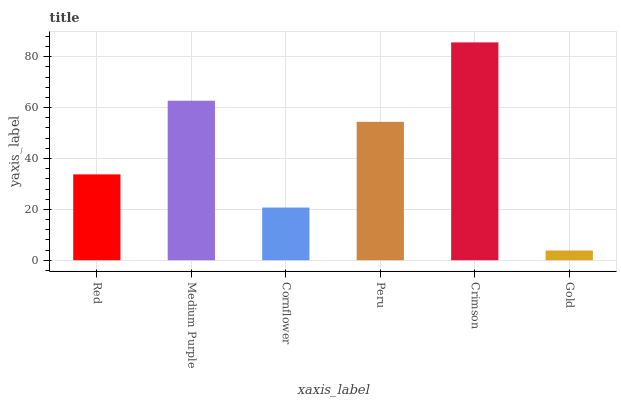Is Gold the minimum?
Answer yes or no. Yes. Is Crimson the maximum?
Answer yes or no. Yes. Is Medium Purple the minimum?
Answer yes or no. No. Is Medium Purple the maximum?
Answer yes or no. No. Is Medium Purple greater than Red?
Answer yes or no. Yes. Is Red less than Medium Purple?
Answer yes or no. Yes. Is Red greater than Medium Purple?
Answer yes or no. No. Is Medium Purple less than Red?
Answer yes or no. No. Is Peru the high median?
Answer yes or no. Yes. Is Red the low median?
Answer yes or no. Yes. Is Red the high median?
Answer yes or no. No. Is Medium Purple the low median?
Answer yes or no. No. 